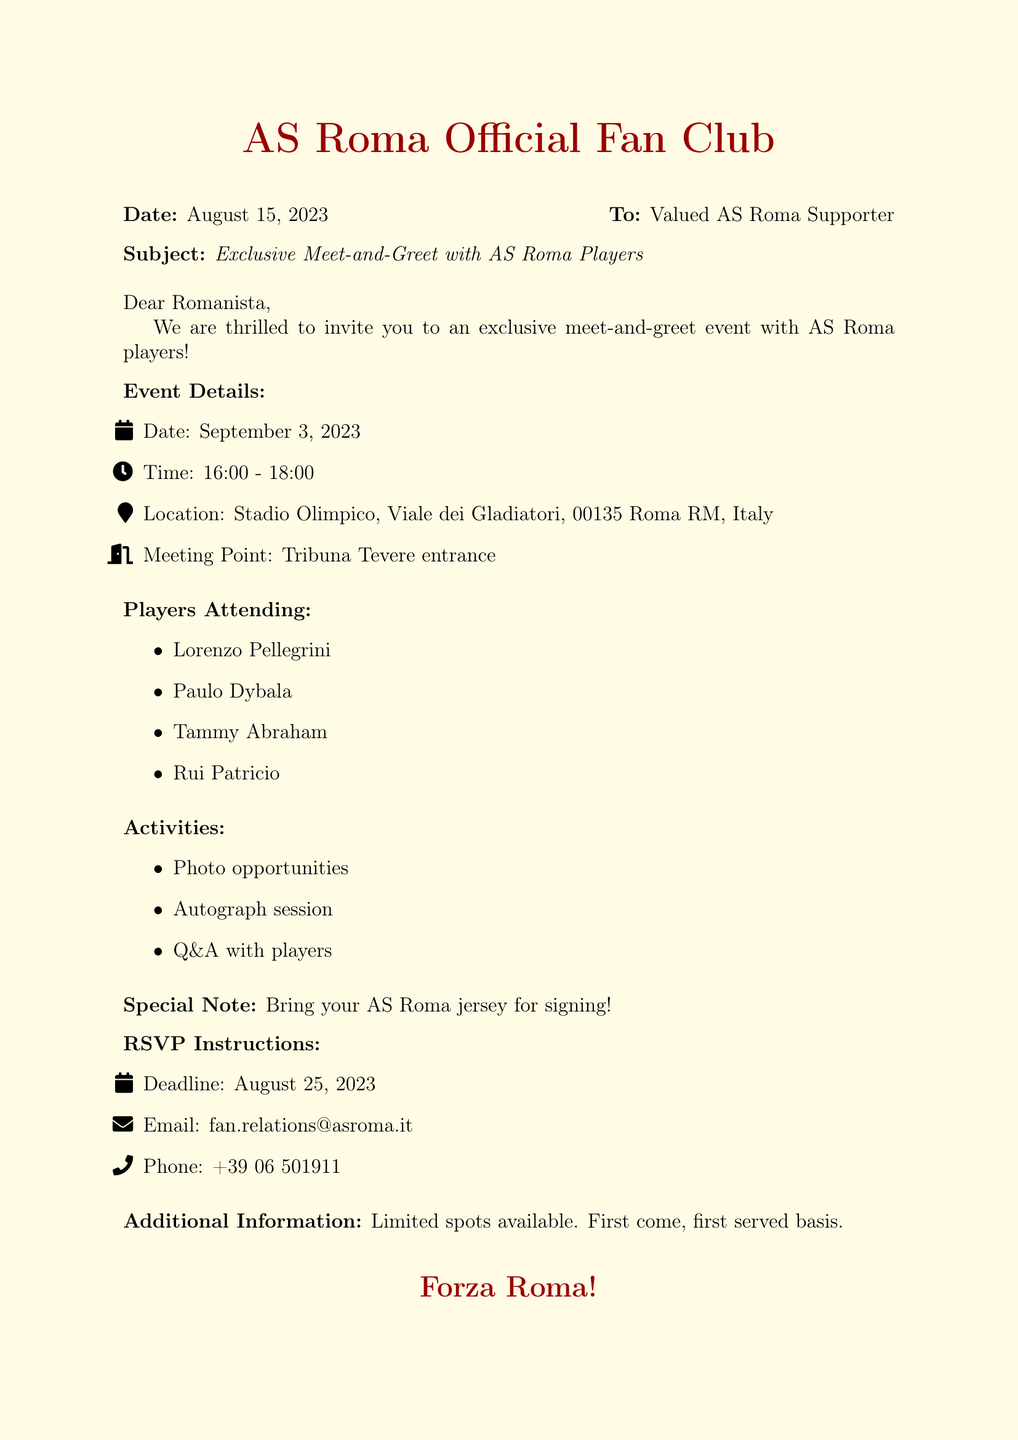What is the date of the event? The date of the event is clearly stated in the document as September 3, 2023.
Answer: September 3, 2023 What time does the event start? The document specifies the time duration for the event as 16:00 - 18:00, with the start time being the first mentioned.
Answer: 16:00 Where is the event taking place? The location of the event is provided as Stadio Olimpico, Viale dei Gladiatori, 00135 Roma RM, Italy.
Answer: Stadio Olimpico, Viale dei Gladiatori, 00135 Roma RM, Italy Who are the players attending? A list of players attending the event is included, and one of them is Paulo Dybala.
Answer: Paulo Dybala What should attendees bring for signing? The document mentions a special note advising attendees to bring their AS Roma jersey for signing.
Answer: AS Roma jersey What is the RSVP deadline? The deadline for RSVPs is explicitly stated as August 25, 2023.
Answer: August 25, 2023 How many players are listed as attending? The document provides a list with four players attending the event.
Answer: Four What is the meeting point? The document specifies the Tribuna Tevere entrance as the meeting point for the event.
Answer: Tribuna Tevere entrance What activities are included in the event? The document outlines several activities, one of which is a photo opportunity.
Answer: Photo opportunities 